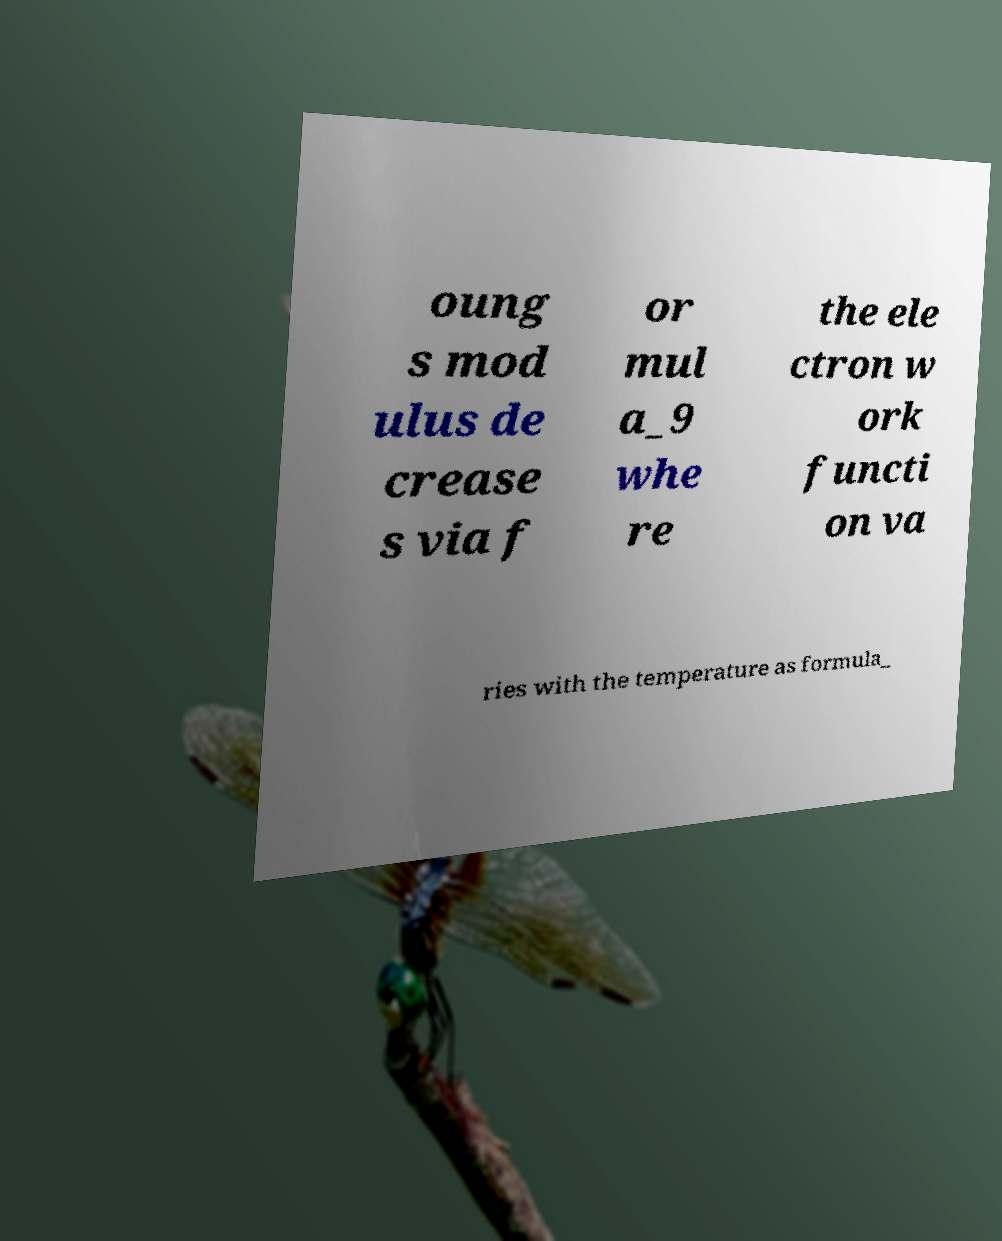Can you read and provide the text displayed in the image?This photo seems to have some interesting text. Can you extract and type it out for me? oung s mod ulus de crease s via f or mul a_9 whe re the ele ctron w ork functi on va ries with the temperature as formula_ 